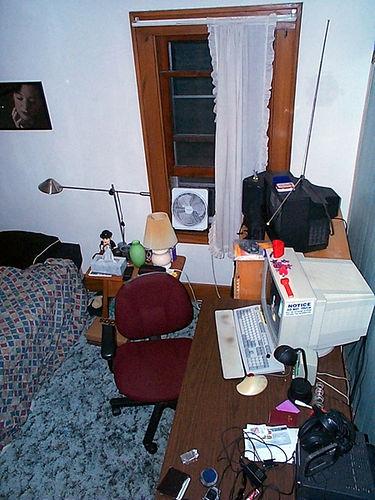What is positioned in the window?
Write a very short answer. Fan. Is this a business office?
Write a very short answer. No. How many chairs in the room?
Quick response, please. 1. Is there a laptop?
Answer briefly. No. 